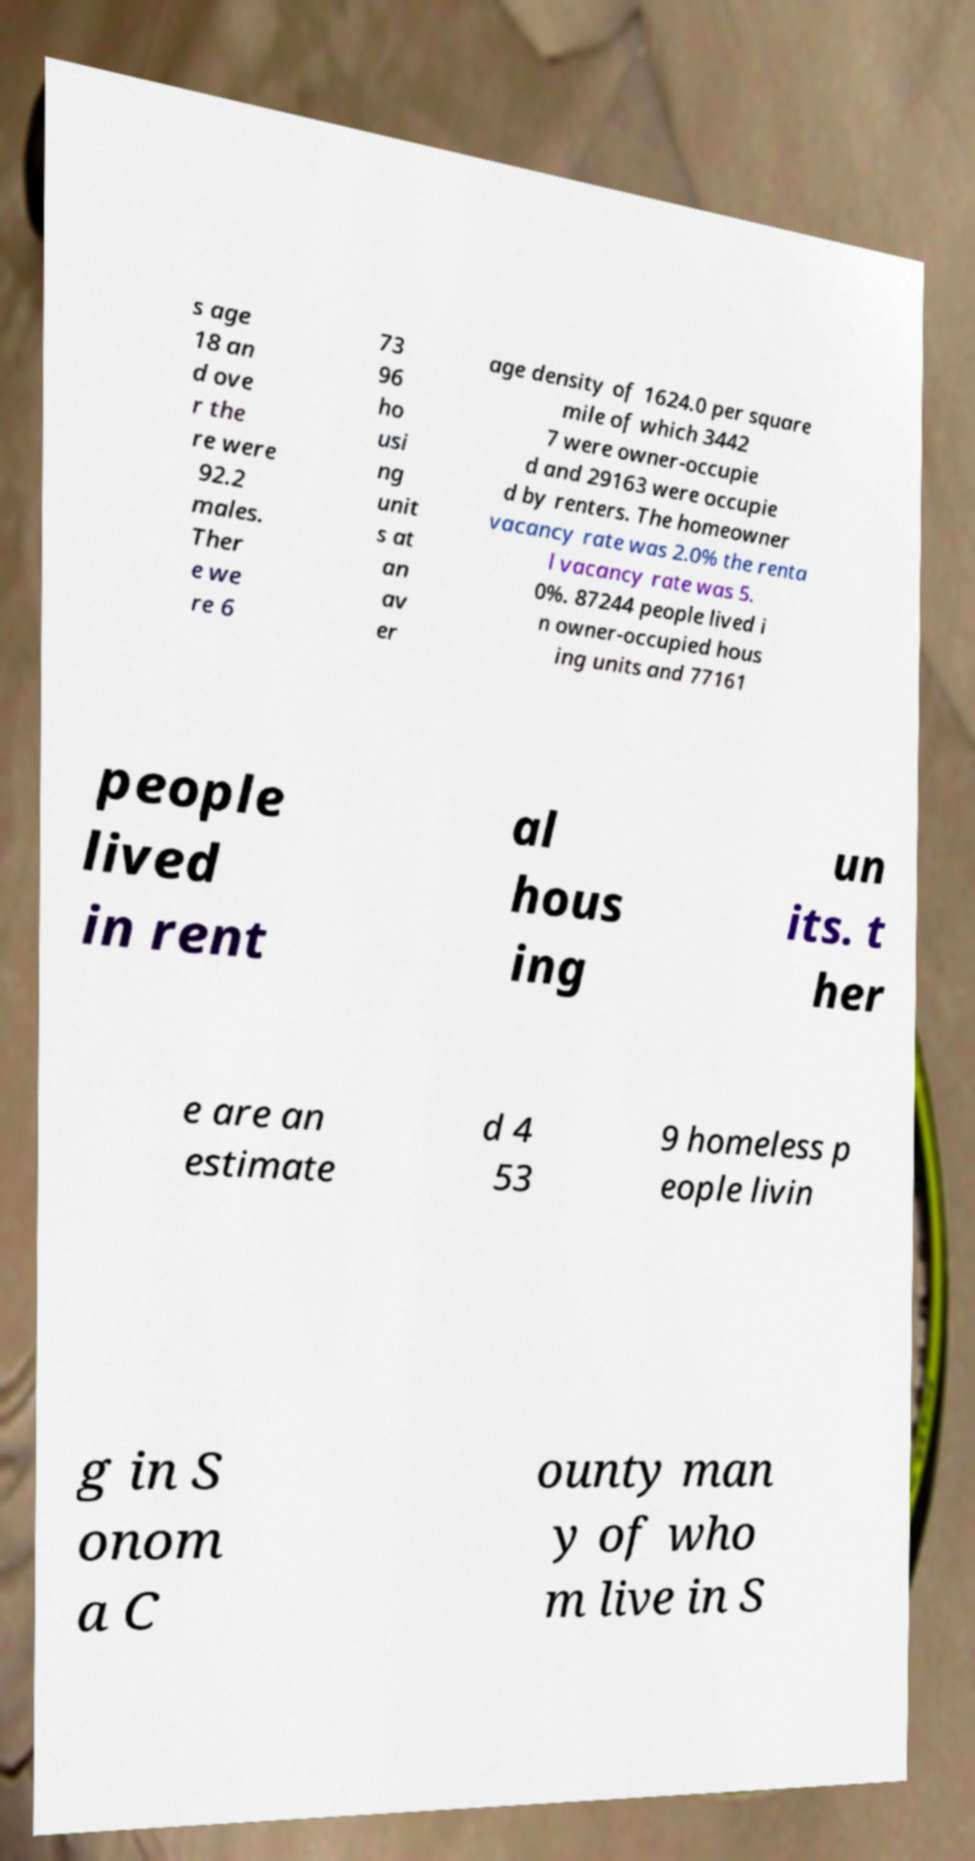Can you read and provide the text displayed in the image?This photo seems to have some interesting text. Can you extract and type it out for me? s age 18 an d ove r the re were 92.2 males. Ther e we re 6 73 96 ho usi ng unit s at an av er age density of 1624.0 per square mile of which 3442 7 were owner-occupie d and 29163 were occupie d by renters. The homeowner vacancy rate was 2.0% the renta l vacancy rate was 5. 0%. 87244 people lived i n owner-occupied hous ing units and 77161 people lived in rent al hous ing un its. t her e are an estimate d 4 53 9 homeless p eople livin g in S onom a C ounty man y of who m live in S 